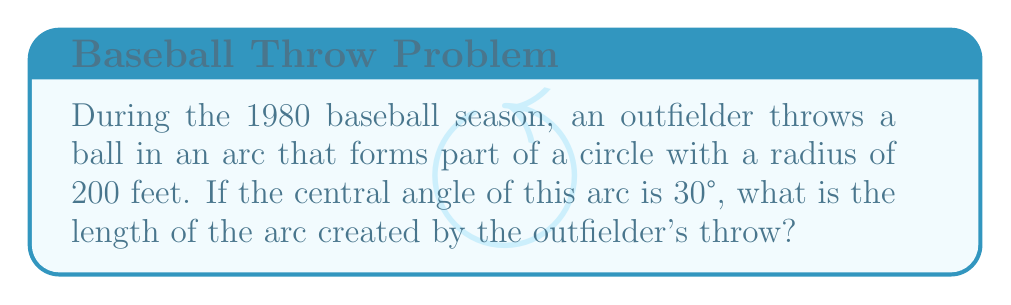Can you solve this math problem? Let's approach this step-by-step:

1) The formula for arc length is:
   $s = r\theta$
   where $s$ is the arc length, $r$ is the radius, and $\theta$ is the central angle in radians.

2) We're given the radius ($r = 200$ feet) and the central angle in degrees (30°).

3) First, we need to convert the angle from degrees to radians:
   $\theta = 30° \times \frac{\pi}{180°} = \frac{\pi}{6}$ radians

4) Now we can substitute these values into our formula:
   $s = 200 \times \frac{\pi}{6}$

5) Simplify:
   $s = \frac{200\pi}{6} = \frac{100\pi}{3}$ feet

Therefore, the length of the arc created by the outfielder's throw is $\frac{100\pi}{3}$ feet.

[asy]
import geometry;

size(200);
pair O = (0,0);
real r = 5;
path c = circle(O, r);
draw(c);
draw(O--(-r,0));
draw(O--(r*cos(pi/6), r*sin(pi/6)));
draw(arc(O, (-r,0), (r*cos(pi/6), r*sin(pi/6))), linewidth(2));
label("30°", (0.5,0.5));
label("r = 200 ft", (r/2,-0.5));
label("Arc", (r*cos(pi/12), r*sin(pi/12)), E);
[/asy]
Answer: $\frac{100\pi}{3}$ feet 